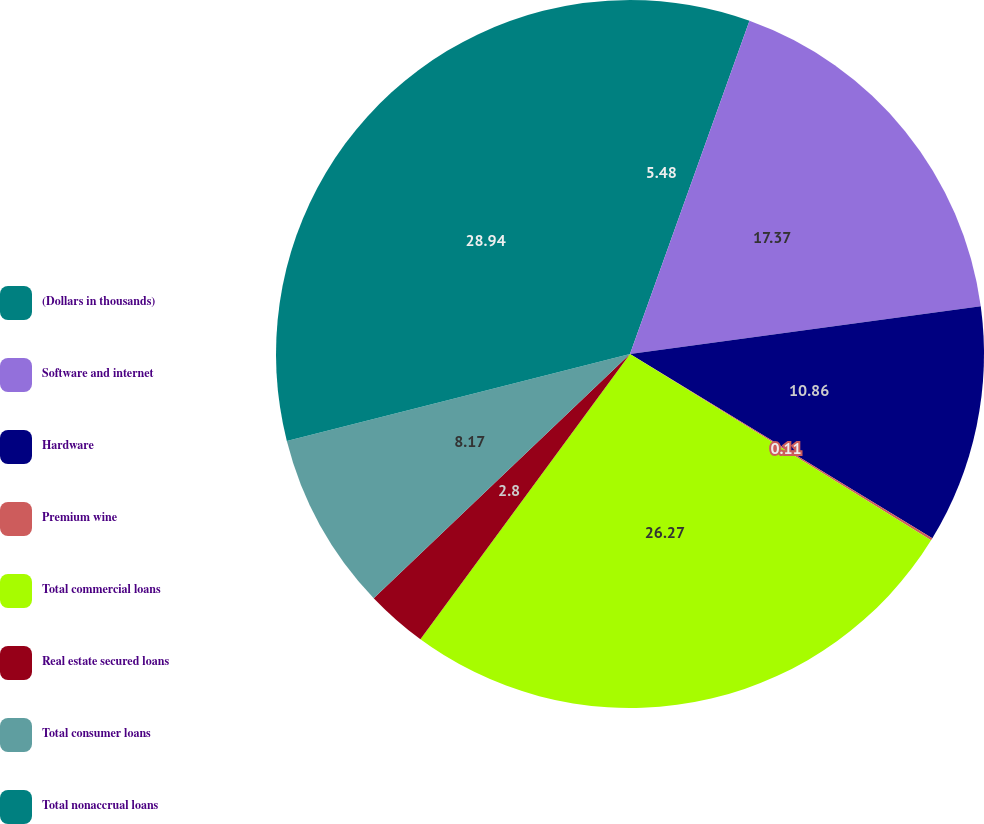Convert chart. <chart><loc_0><loc_0><loc_500><loc_500><pie_chart><fcel>(Dollars in thousands)<fcel>Software and internet<fcel>Hardware<fcel>Premium wine<fcel>Total commercial loans<fcel>Real estate secured loans<fcel>Total consumer loans<fcel>Total nonaccrual loans<nl><fcel>5.48%<fcel>17.37%<fcel>10.86%<fcel>0.11%<fcel>26.27%<fcel>2.8%<fcel>8.17%<fcel>28.95%<nl></chart> 